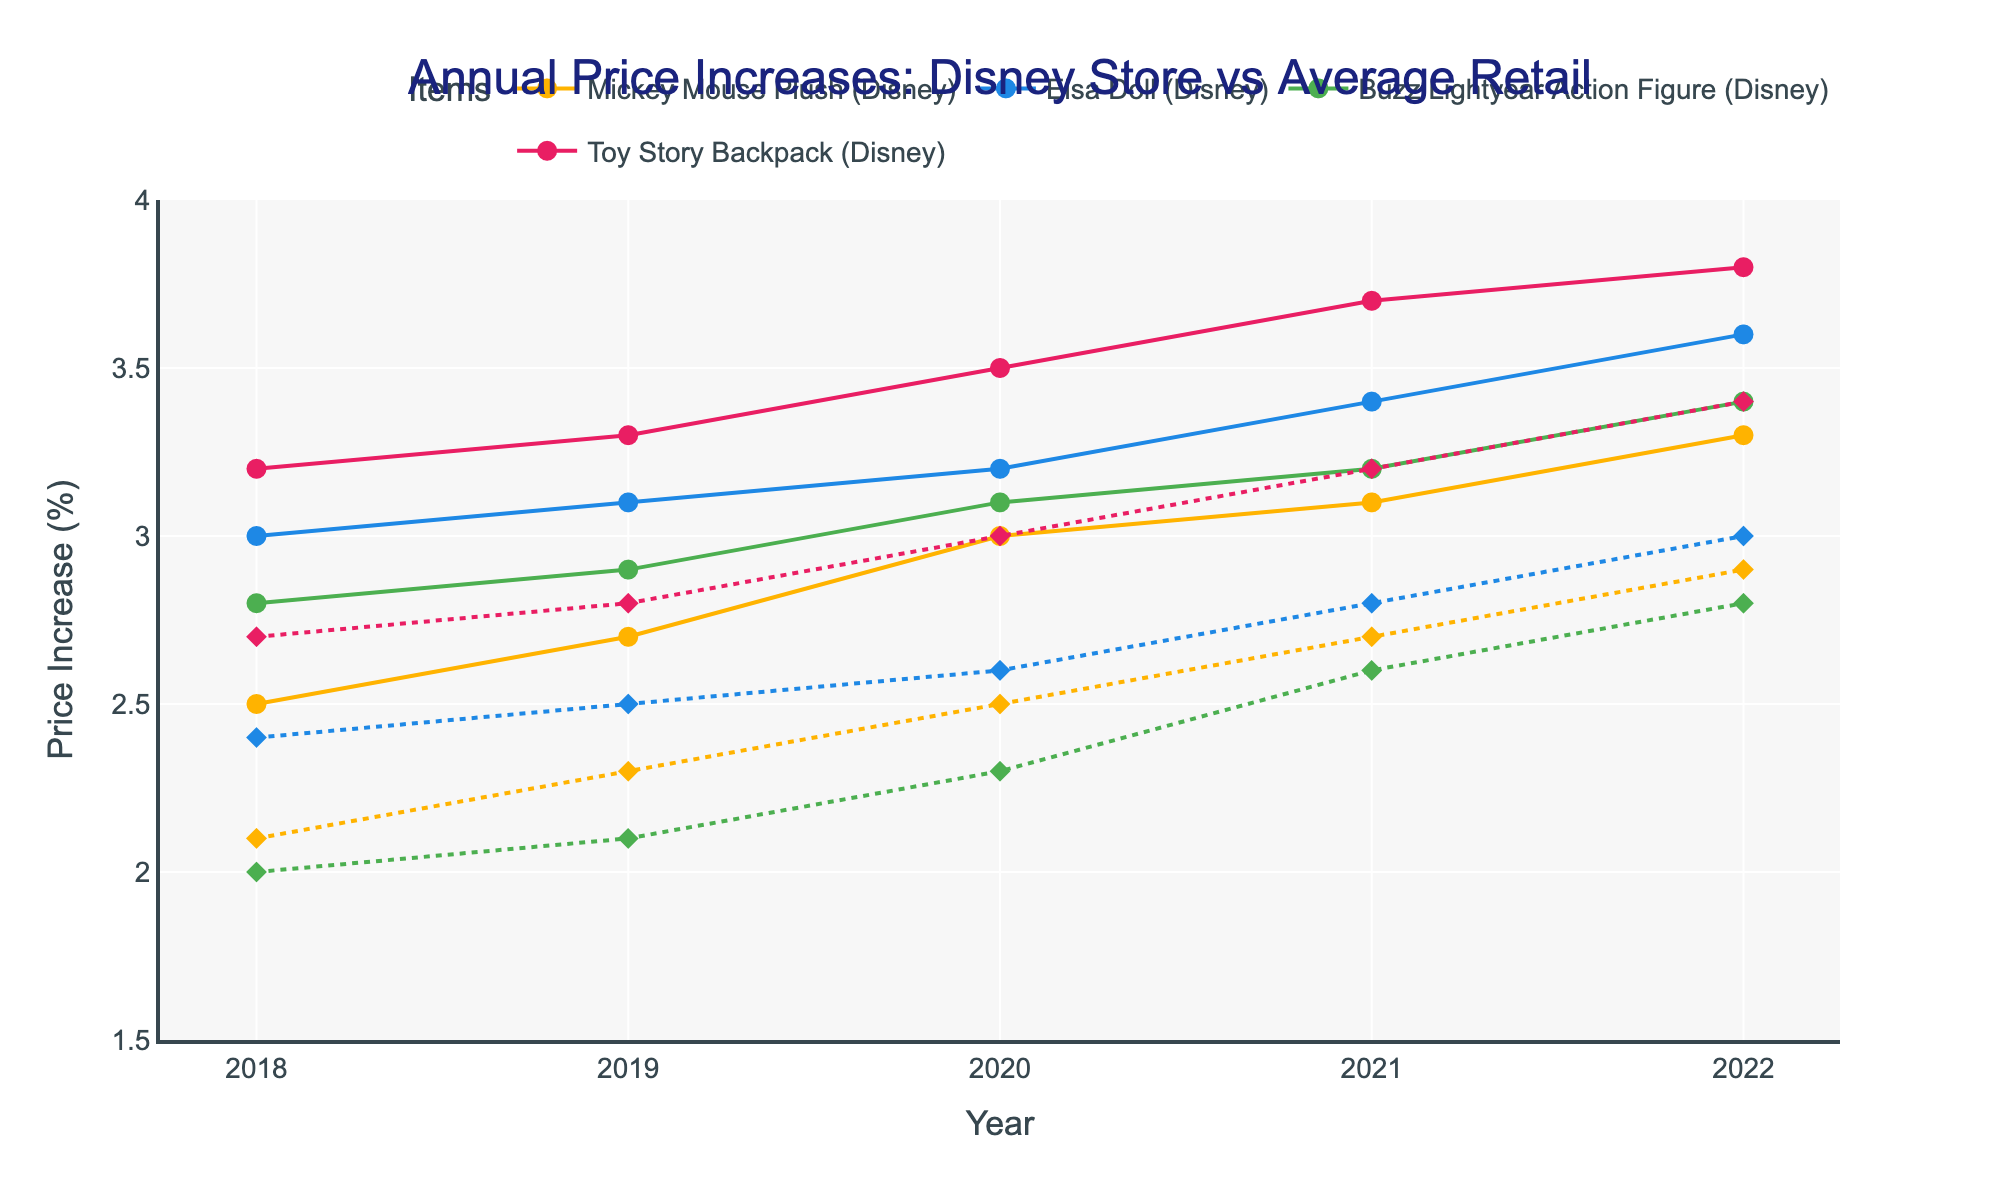What is the title of the plot? The title is displayed at the top center of the plot.
Answer: Annual Price Increases: Disney Store vs Average Retail Which year had the highest price increase for the Mickey Mouse Plush at Disney stores? By looking at the markers on the plot for the Mickey Mouse Plush (Disney) across the years, the highest point is observed in 2022.
Answer: 2022 How does the price increase for the Elsa Doll at Disney stores in 2020 compare with the average retail price increase the same year? Identify the markers for the Elsa Doll (Disney) and Average Retail in 2020. Compare the Y values of the markers.
Answer: Disney: 3.2%, Retail: 2.6% What is the average price increase for the Toy Story Backpack at Disney stores from 2018 to 2022? Sum the values of price increases for each year for the Toy Story Backpack (3.2 in 2018, 3.3 in 2019, 3.5 in 2020, 3.7 in 2021, and 3.8 in 2022) and then divide by the number of years (5).
Answer: 3.5% Is there any year where the price increase for Buzz Lightyear Action Figure at Disney stores is less than the average retail price increase? Compare the Disney store price increases with the average retail price increases for Buzz Lightyear Action Figure for each year. All Disney price increases are higher.
Answer: No Which item shows the largest difference between Disney store price increase and average retail price increase in 2021? Calculate the difference between the Disney store price increase and the average retail price increase for each item in 2021 (Mickey Mouse Plush, Elsa Doll, Buzz Lightyear Action Figure, Toy Story Backpack). The largest difference is for Toy Story Backpack (3.7 - 3.2).
Answer: Toy Story Backpack How did the average retail price increase across all items change from 2018 to 2022? Take the average of the average retail price increases at the beginning (2018) and at the end (2022). For 2018: (2.1 + 2.4 + 2.0 + 2.7) / 4 = 2.3. For 2022: (2.9 + 3.0 + 2.8 + 3.4) / 4 = 3.025. Compare these two values.
Answer: 2.3% to 3.025% In which year did the Elsa Doll and Mickey Mouse Plush have the exact same price increase at Disney stores? Compare the Disney store price increases year by year for Elsa Doll and Mickey Mouse Plush. The year where both have the same value is 2020.
Answer: 2020 